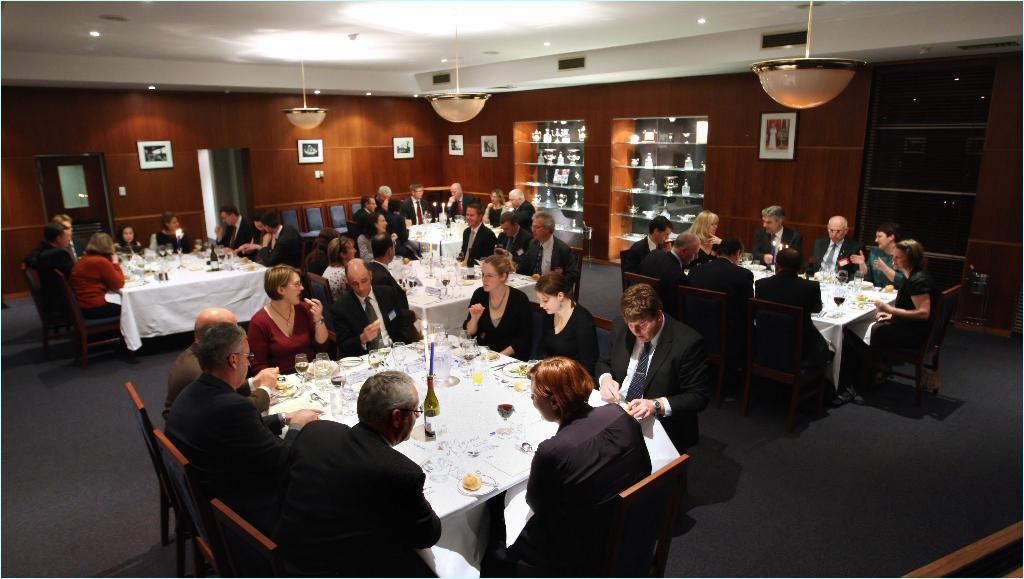How many people are in the image? There is a group of persons in the image. What are the persons doing in the image? The persons are sitting around a table and having drinks and food. What type of pies are being served to the group in the image? There is no mention of pies in the image; the persons are having drinks and food, but the specific type of food is not specified. 